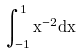<formula> <loc_0><loc_0><loc_500><loc_500>\int _ { - 1 } ^ { 1 } x ^ { - 2 } d x</formula> 